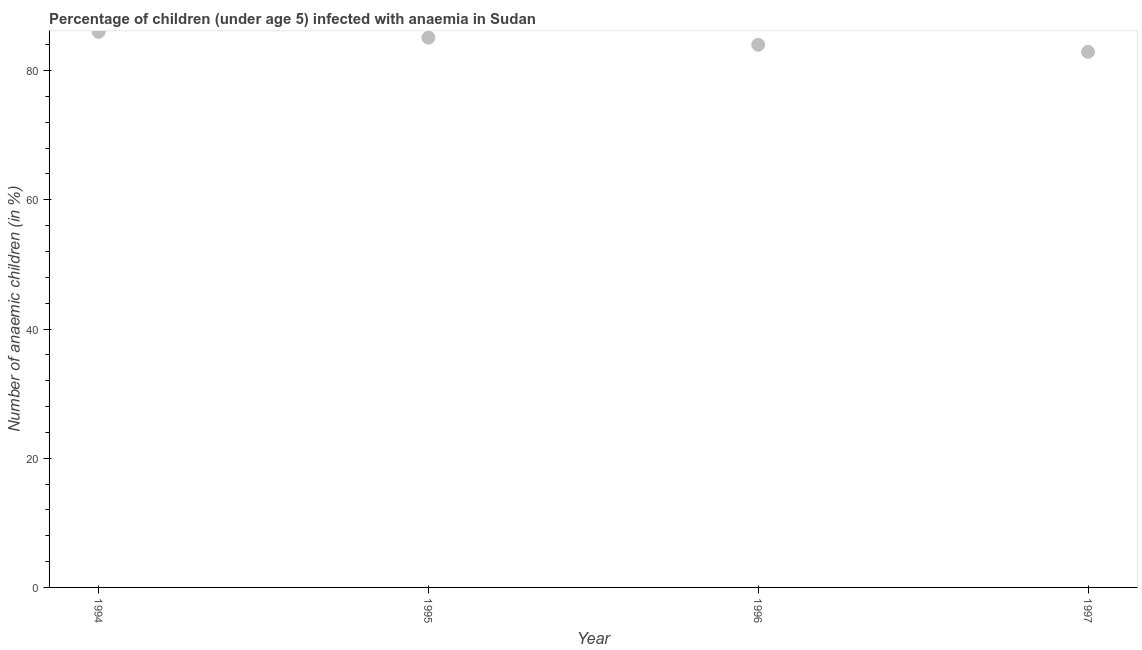What is the number of anaemic children in 1995?
Make the answer very short. 85.1. Across all years, what is the minimum number of anaemic children?
Ensure brevity in your answer.  82.9. In which year was the number of anaemic children maximum?
Make the answer very short. 1994. What is the sum of the number of anaemic children?
Give a very brief answer. 338. What is the difference between the number of anaemic children in 1994 and 1997?
Give a very brief answer. 3.1. What is the average number of anaemic children per year?
Provide a short and direct response. 84.5. What is the median number of anaemic children?
Your answer should be very brief. 84.55. Do a majority of the years between 1996 and 1995 (inclusive) have number of anaemic children greater than 4 %?
Provide a short and direct response. No. What is the ratio of the number of anaemic children in 1995 to that in 1997?
Your answer should be very brief. 1.03. What is the difference between the highest and the second highest number of anaemic children?
Provide a short and direct response. 0.9. What is the difference between the highest and the lowest number of anaemic children?
Ensure brevity in your answer.  3.1. In how many years, is the number of anaemic children greater than the average number of anaemic children taken over all years?
Offer a very short reply. 2. Does the graph contain any zero values?
Give a very brief answer. No. What is the title of the graph?
Your answer should be compact. Percentage of children (under age 5) infected with anaemia in Sudan. What is the label or title of the X-axis?
Your answer should be very brief. Year. What is the label or title of the Y-axis?
Keep it short and to the point. Number of anaemic children (in %). What is the Number of anaemic children (in %) in 1994?
Give a very brief answer. 86. What is the Number of anaemic children (in %) in 1995?
Your response must be concise. 85.1. What is the Number of anaemic children (in %) in 1997?
Keep it short and to the point. 82.9. What is the difference between the Number of anaemic children (in %) in 1994 and 1996?
Keep it short and to the point. 2. What is the difference between the Number of anaemic children (in %) in 1994 and 1997?
Your answer should be compact. 3.1. What is the difference between the Number of anaemic children (in %) in 1996 and 1997?
Offer a terse response. 1.1. What is the ratio of the Number of anaemic children (in %) in 1994 to that in 1995?
Ensure brevity in your answer.  1.01. What is the ratio of the Number of anaemic children (in %) in 1995 to that in 1996?
Keep it short and to the point. 1.01. What is the ratio of the Number of anaemic children (in %) in 1995 to that in 1997?
Keep it short and to the point. 1.03. What is the ratio of the Number of anaemic children (in %) in 1996 to that in 1997?
Offer a terse response. 1.01. 